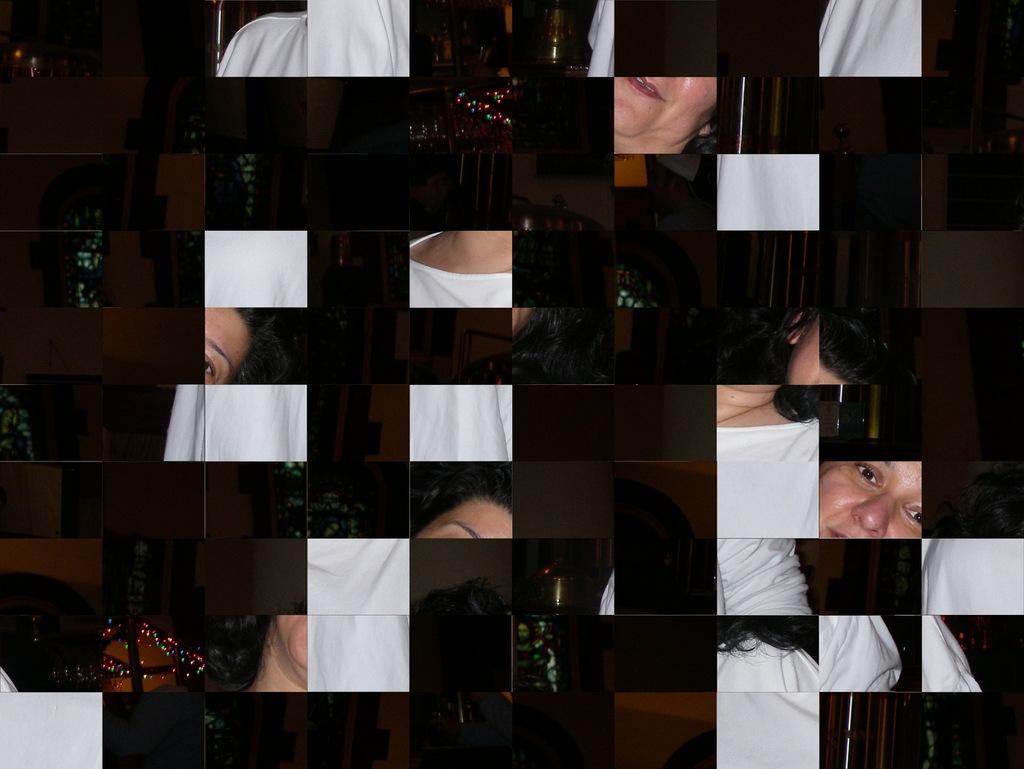Describe this image in one or two sentences. in this picture there is a puzzle in the center of the image, which is not arranged. 